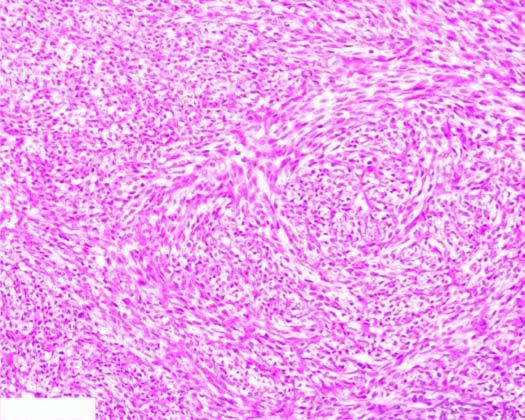re the tumour cells arranged in storiform or cartwheel pattern?
Answer the question using a single word or phrase. Yes 